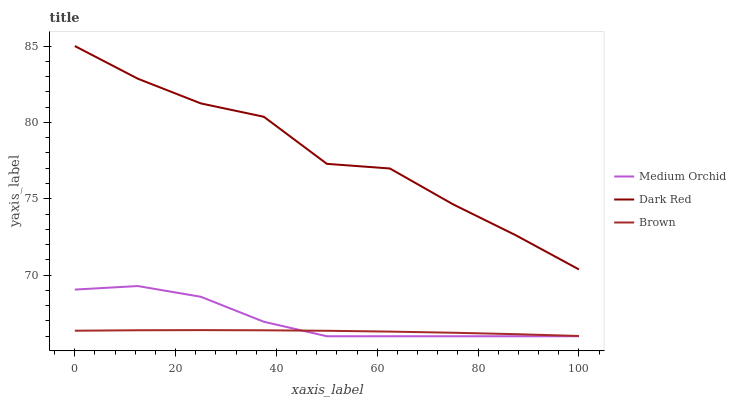Does Brown have the minimum area under the curve?
Answer yes or no. Yes. Does Dark Red have the maximum area under the curve?
Answer yes or no. Yes. Does Medium Orchid have the minimum area under the curve?
Answer yes or no. No. Does Medium Orchid have the maximum area under the curve?
Answer yes or no. No. Is Brown the smoothest?
Answer yes or no. Yes. Is Dark Red the roughest?
Answer yes or no. Yes. Is Medium Orchid the smoothest?
Answer yes or no. No. Is Medium Orchid the roughest?
Answer yes or no. No. Does Medium Orchid have the lowest value?
Answer yes or no. Yes. Does Brown have the lowest value?
Answer yes or no. No. Does Dark Red have the highest value?
Answer yes or no. Yes. Does Medium Orchid have the highest value?
Answer yes or no. No. Is Medium Orchid less than Dark Red?
Answer yes or no. Yes. Is Dark Red greater than Brown?
Answer yes or no. Yes. Does Medium Orchid intersect Brown?
Answer yes or no. Yes. Is Medium Orchid less than Brown?
Answer yes or no. No. Is Medium Orchid greater than Brown?
Answer yes or no. No. Does Medium Orchid intersect Dark Red?
Answer yes or no. No. 